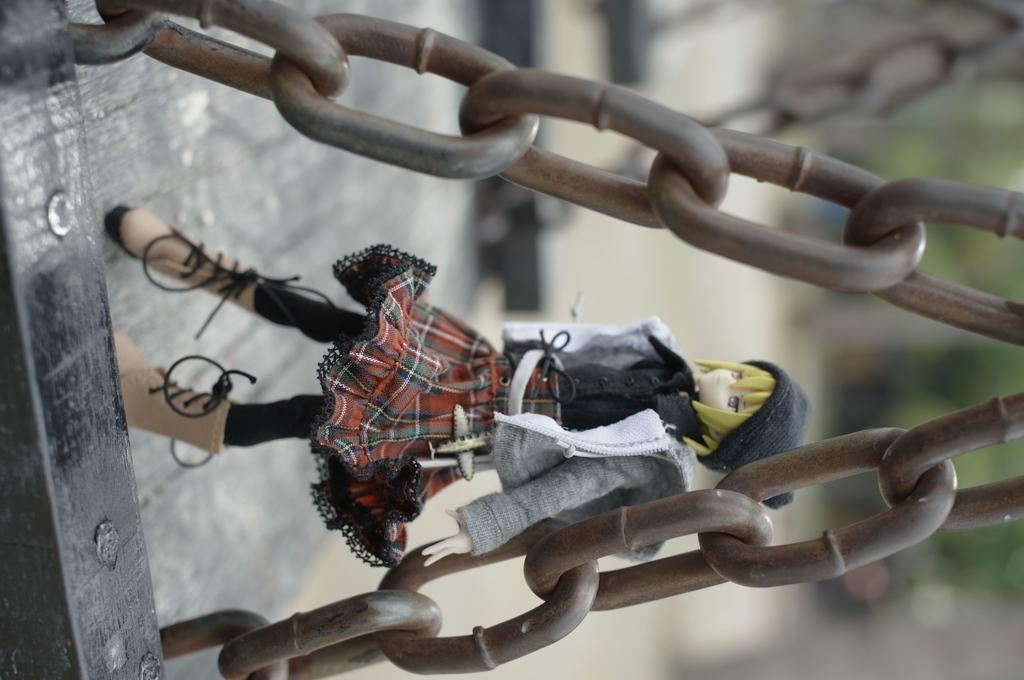What can be seen in the foreground of the image? In the foreground of the image, there are chains, a wooden object, and a toy. Can you describe the wooden object in the foreground? The wooden object in the foreground is not specified in the facts, but it is present along with the chains and toy. What is the condition of the background in the image? The background of the image is blurred. Can you tell me how many monkeys are playing basketball in the image? There are no monkeys or basketballs present in the image. What type of lead is being used to create the wooden object in the image? There is no information about the type of lead used in the image, as the facts only mention the presence of a wooden object. 